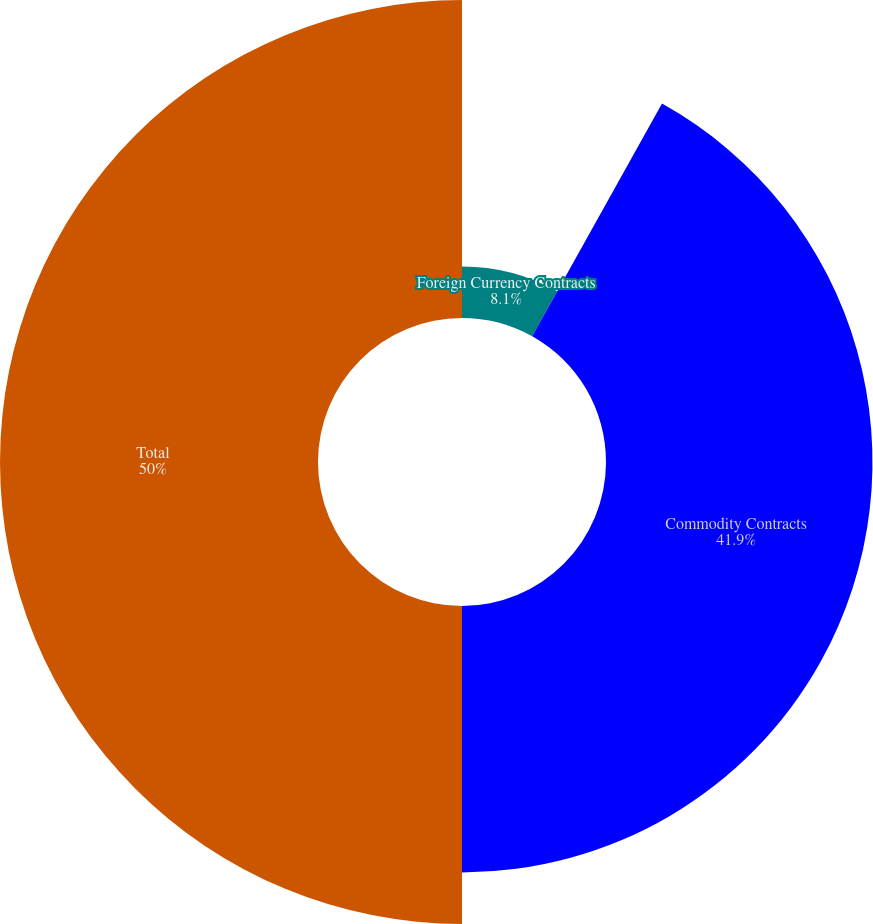Convert chart to OTSL. <chart><loc_0><loc_0><loc_500><loc_500><pie_chart><fcel>Foreign Currency Contracts<fcel>Commodity Contracts<fcel>Total<nl><fcel>8.1%<fcel>41.9%<fcel>50.0%<nl></chart> 